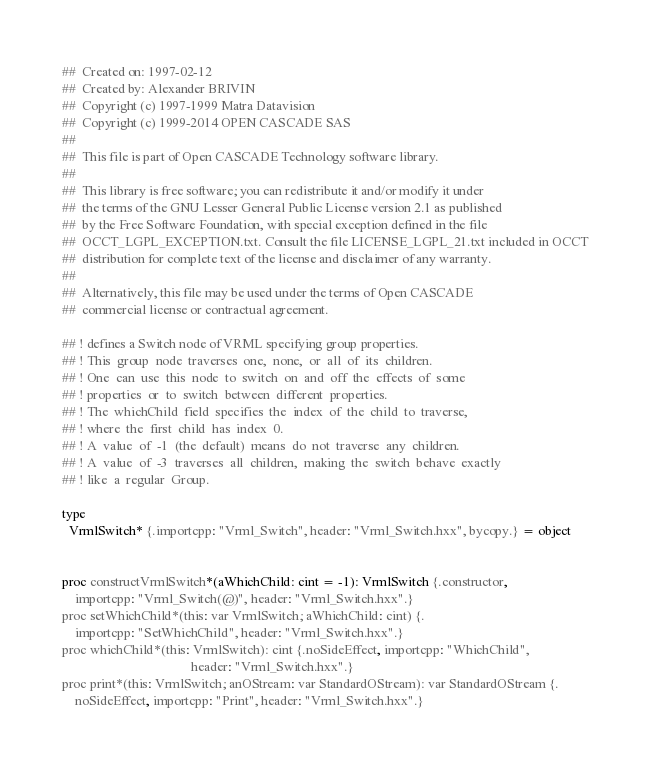Convert code to text. <code><loc_0><loc_0><loc_500><loc_500><_Nim_>##  Created on: 1997-02-12
##  Created by: Alexander BRIVIN
##  Copyright (c) 1997-1999 Matra Datavision
##  Copyright (c) 1999-2014 OPEN CASCADE SAS
##
##  This file is part of Open CASCADE Technology software library.
##
##  This library is free software; you can redistribute it and/or modify it under
##  the terms of the GNU Lesser General Public License version 2.1 as published
##  by the Free Software Foundation, with special exception defined in the file
##  OCCT_LGPL_EXCEPTION.txt. Consult the file LICENSE_LGPL_21.txt included in OCCT
##  distribution for complete text of the license and disclaimer of any warranty.
##
##  Alternatively, this file may be used under the terms of Open CASCADE
##  commercial license or contractual agreement.

## ! defines a Switch node of VRML specifying group properties.
## ! This  group  node  traverses  one,  none,  or  all  of  its  children.
## ! One  can  use  this  node  to  switch  on  and  off  the  effects  of  some
## ! properties  or  to  switch  between  different  properties.
## ! The  whichChild  field  specifies  the  index  of  the  child  to  traverse,
## ! where  the  first  child  has  index  0.
## ! A  value  of  -1  (the  default)  means  do  not  traverse  any  children.
## ! A  value  of  -3  traverses  all  children,  making  the  switch  behave  exactly
## ! like  a  regular  Group.

type
  VrmlSwitch* {.importcpp: "Vrml_Switch", header: "Vrml_Switch.hxx", bycopy.} = object


proc constructVrmlSwitch*(aWhichChild: cint = -1): VrmlSwitch {.constructor,
    importcpp: "Vrml_Switch(@)", header: "Vrml_Switch.hxx".}
proc setWhichChild*(this: var VrmlSwitch; aWhichChild: cint) {.
    importcpp: "SetWhichChild", header: "Vrml_Switch.hxx".}
proc whichChild*(this: VrmlSwitch): cint {.noSideEffect, importcpp: "WhichChild",
                                       header: "Vrml_Switch.hxx".}
proc print*(this: VrmlSwitch; anOStream: var StandardOStream): var StandardOStream {.
    noSideEffect, importcpp: "Print", header: "Vrml_Switch.hxx".}

























</code> 